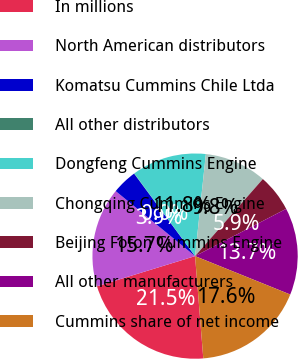<chart> <loc_0><loc_0><loc_500><loc_500><pie_chart><fcel>In millions<fcel>North American distributors<fcel>Komatsu Cummins Chile Ltda<fcel>All other distributors<fcel>Dongfeng Cummins Engine<fcel>Chongqing Cummins Engine<fcel>Beijing Foton Cummins Engine<fcel>All other manufacturers<fcel>Cummins share of net income<nl><fcel>21.53%<fcel>15.67%<fcel>3.95%<fcel>0.04%<fcel>11.76%<fcel>9.81%<fcel>5.9%<fcel>13.72%<fcel>17.62%<nl></chart> 